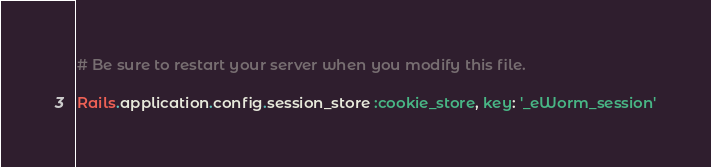<code> <loc_0><loc_0><loc_500><loc_500><_Ruby_># Be sure to restart your server when you modify this file.

Rails.application.config.session_store :cookie_store, key: '_eWorm_session'
</code> 